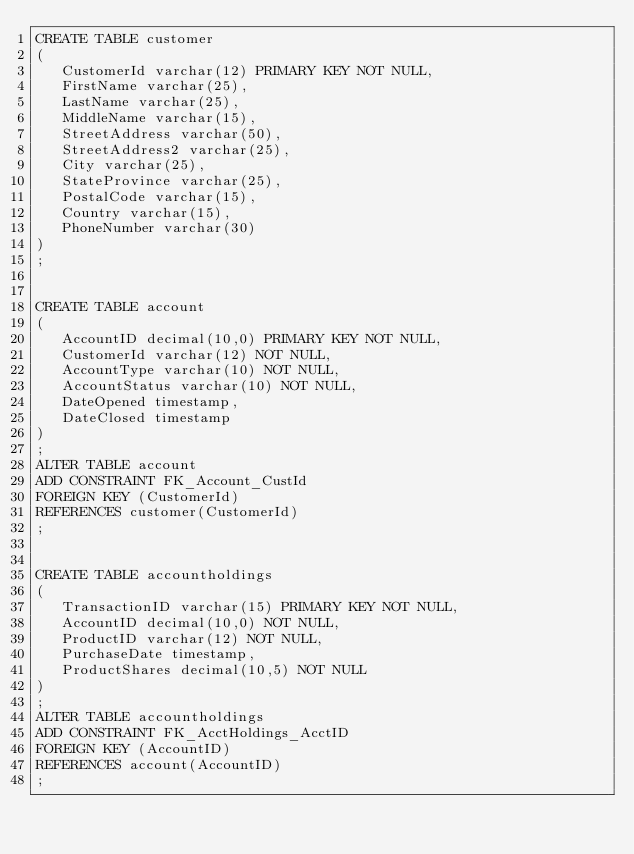Convert code to text. <code><loc_0><loc_0><loc_500><loc_500><_SQL_>CREATE TABLE customer
(
   CustomerId varchar(12) PRIMARY KEY NOT NULL,
   FirstName varchar(25),
   LastName varchar(25),
   MiddleName varchar(15),
   StreetAddress varchar(50),
   StreetAddress2 varchar(25),
   City varchar(25),
   StateProvince varchar(25),
   PostalCode varchar(15),
   Country varchar(15),
   PhoneNumber varchar(30)
)
;


CREATE TABLE account
(
   AccountID decimal(10,0) PRIMARY KEY NOT NULL,
   CustomerId varchar(12) NOT NULL,
   AccountType varchar(10) NOT NULL,
   AccountStatus varchar(10) NOT NULL,
   DateOpened timestamp,
   DateClosed timestamp
)
;
ALTER TABLE account
ADD CONSTRAINT FK_Account_CustId
FOREIGN KEY (CustomerId)
REFERENCES customer(CustomerId)
;


CREATE TABLE accountholdings
(
   TransactionID varchar(15) PRIMARY KEY NOT NULL,
   AccountID decimal(10,0) NOT NULL,
   ProductID varchar(12) NOT NULL,
   PurchaseDate timestamp,
   ProductShares decimal(10,5) NOT NULL
)
;
ALTER TABLE accountholdings
ADD CONSTRAINT FK_AcctHoldings_AcctID
FOREIGN KEY (AccountID)
REFERENCES account(AccountID)
;

</code> 